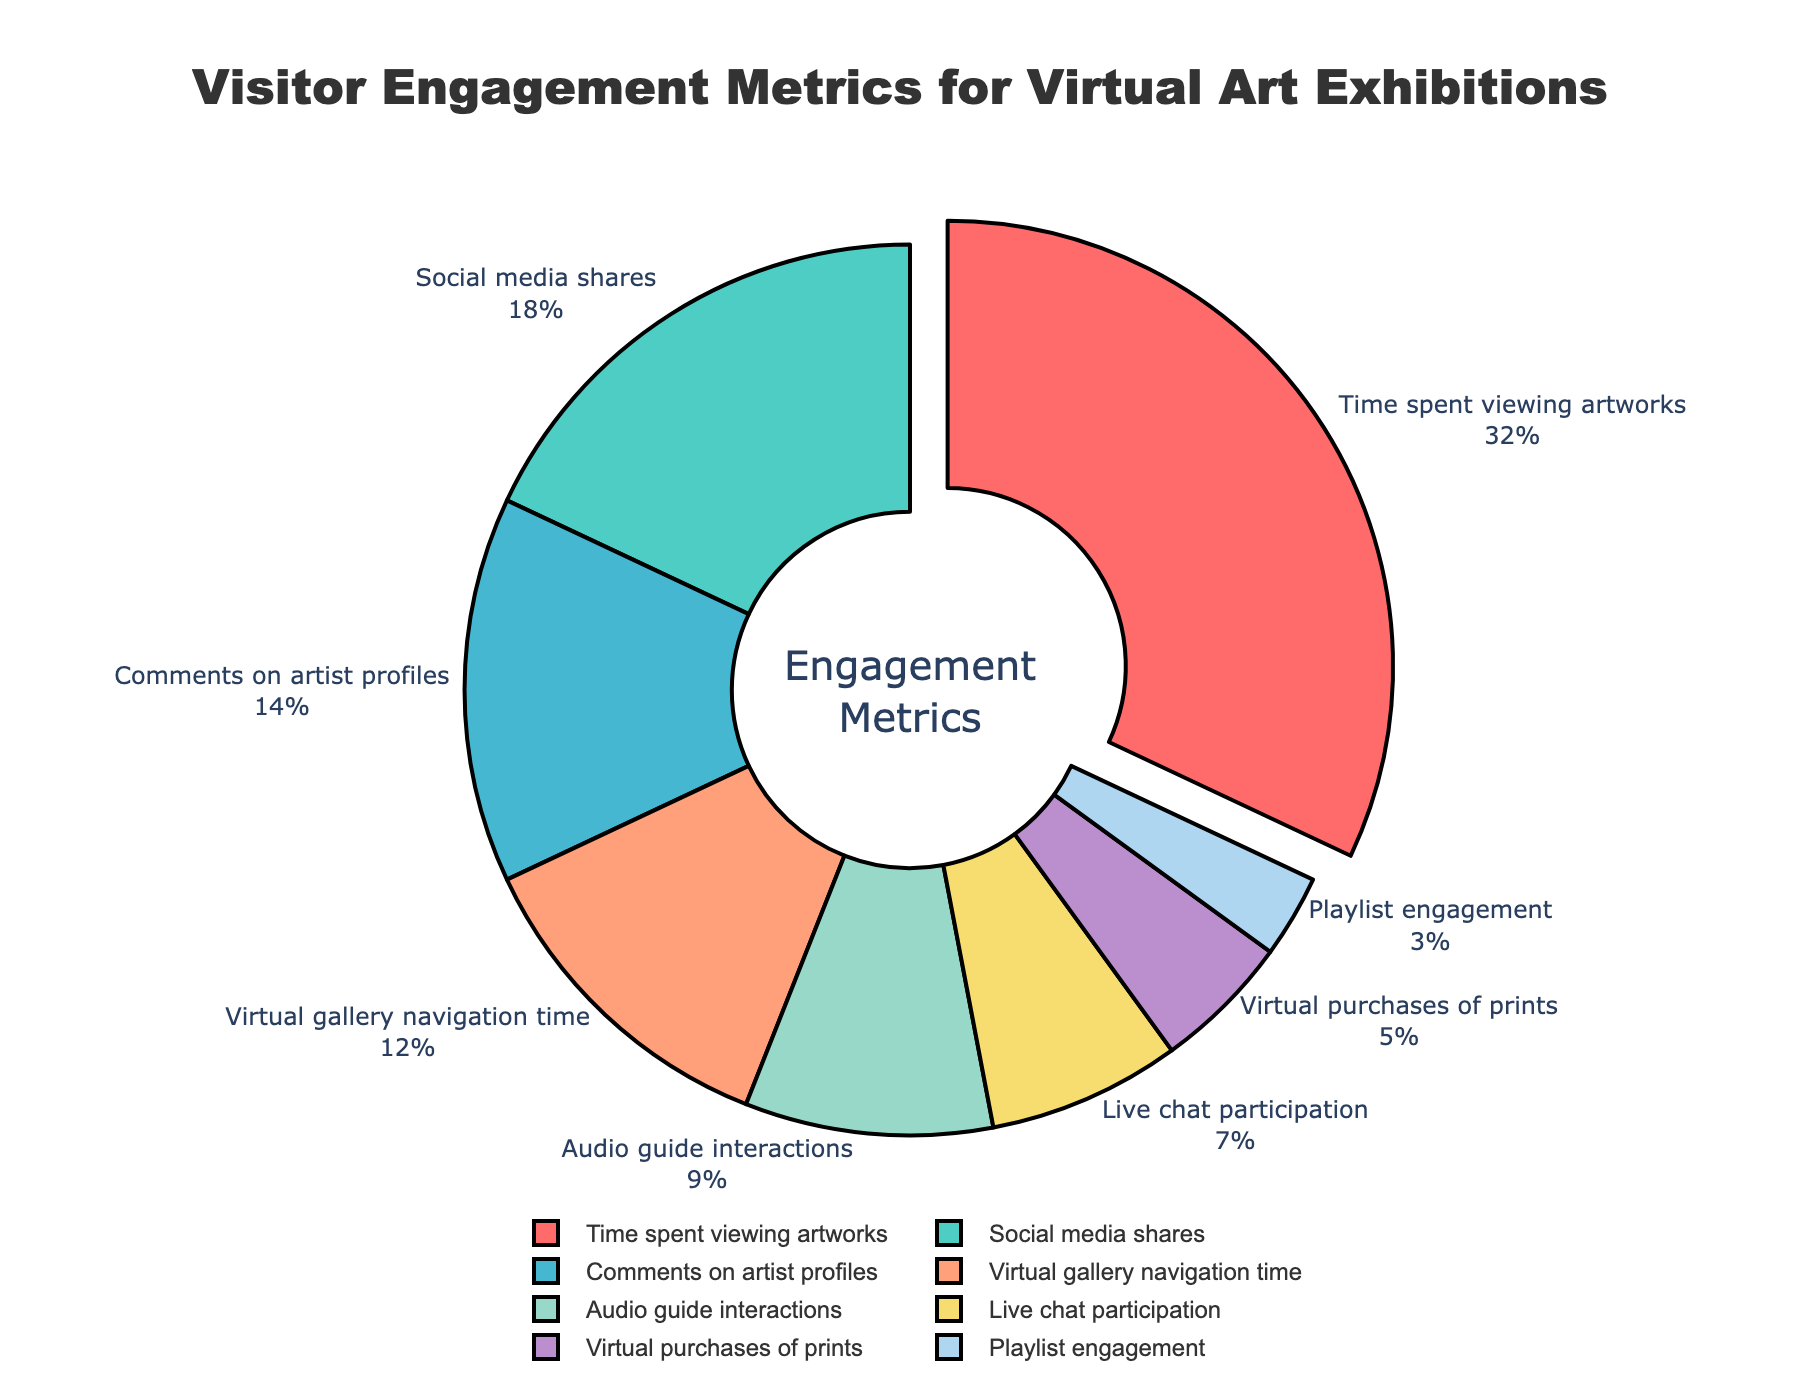Which engagement metric has the highest proportion of visitor engagement? The segment that is pulled out slightly from the pie chart represents the metric with the highest proportion. It indicated by the color with red and labeled as "Time spent viewing artworks" at 32%.
Answer: Time spent viewing artworks What is the total percentage of visitor engagement for social media shares and comments on artist profiles combined? First, locate the segments for social media shares (18%) and comments on artist profiles (14%). Add these two percentages together: 18% + 14% = 32%.
Answer: 32% Which engagement metric has the lowest proportion, and what is its percentage? Find the smallest segment in the pie chart, which is represented by the color light blue and labeled as "Playlist engagement" with 3%.
Answer: Playlist engagement, 3% How does the percentage of live chat participation compare to that of audio guide interactions? Locate the segments for live chat participation (7%) and audio guide interactions (9%). Notice that 7% is less than 9%.
Answer: Live chat participation is less than audio guide interactions What is the difference in engagement percentage between virtual purchases of prints and live chat participation? Locate the segments for virtual purchases of prints (5%) and live chat participation (7%). Subtract 5% from 7%: 7% - 5% = 2%.
Answer: 2% Among the listed metrics, which three have the closest proportion of visitor engagement, and what are their percentages? The segments with closest percentages are those for comments on artist profiles (14%), virtual gallery navigation time (12%), and audio guide interactions (9%). These are relatively close to each other when viewed.
Answer: Comments on artist profiles (14%), Virtual gallery navigation time (12%), Audio guide interactions (9%) What percentage of total visitor engagement is attributed to metrics related to social interactions, considering social media shares, comments on artist profiles, and live chat participation? Sum the percentages of social media shares (18%), comments on artist profiles (14%), and live chat participation (7%): 18% + 14% + 7% = 39%.
Answer: 39% If "Time spent viewing artworks" and "Social media shares" are combined into a single metric, what percentage of the total engagement does it represent? Add the percentages of time spent viewing artworks (32%) and social media shares (18%): 32% + 18% = 50%.
Answer: 50% 